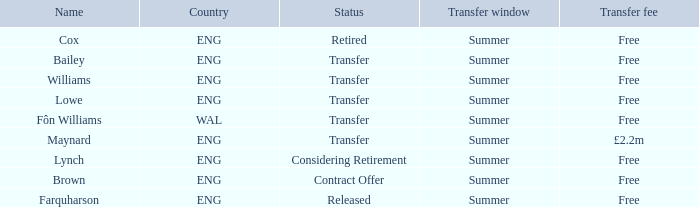What is the status of the Eng Country from the Maynard name? Transfer. 